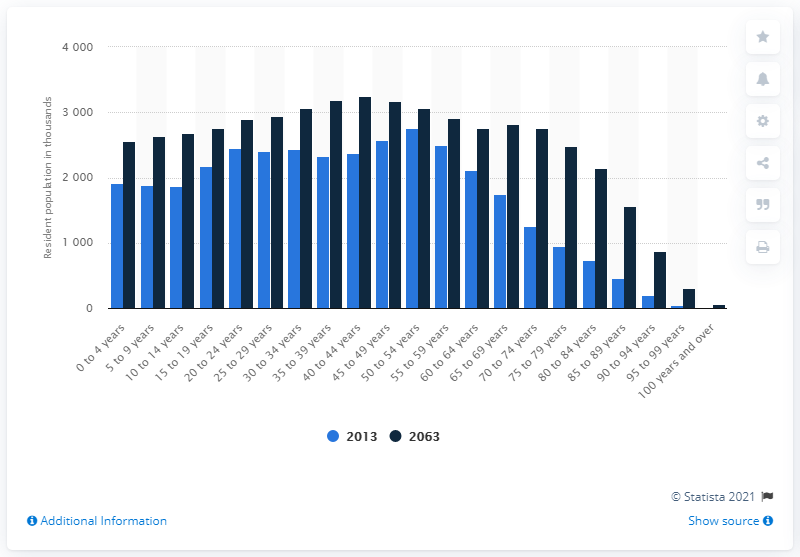Mention a couple of crucial points in this snapshot. As of 2063, it is projected that the population in the age group from 20 to 24 years in Canada will be approximately 2895.5 people. 